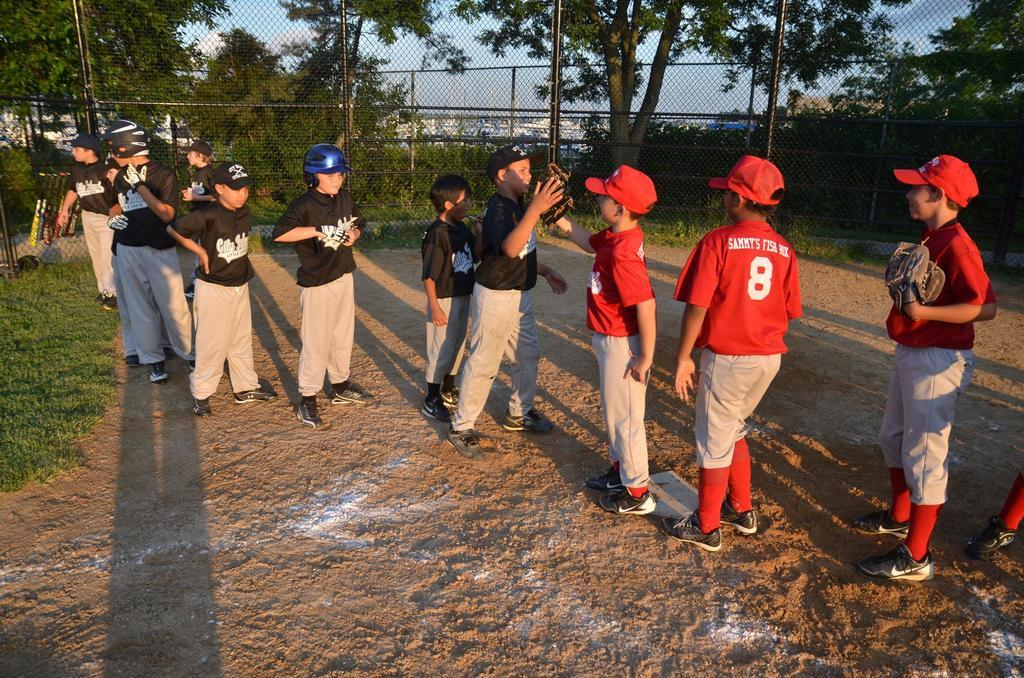<image>
Summarize the visual content of the image. the number 8 on the back of a person's jersey 